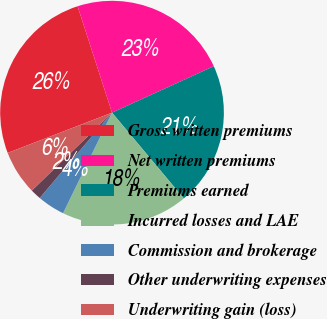Convert chart to OTSL. <chart><loc_0><loc_0><loc_500><loc_500><pie_chart><fcel>Gross written premiums<fcel>Net written premiums<fcel>Premiums earned<fcel>Incurred losses and LAE<fcel>Commission and brokerage<fcel>Other underwriting expenses<fcel>Underwriting gain (loss)<nl><fcel>25.88%<fcel>23.16%<fcel>20.73%<fcel>18.3%<fcel>3.98%<fcel>1.54%<fcel>6.41%<nl></chart> 